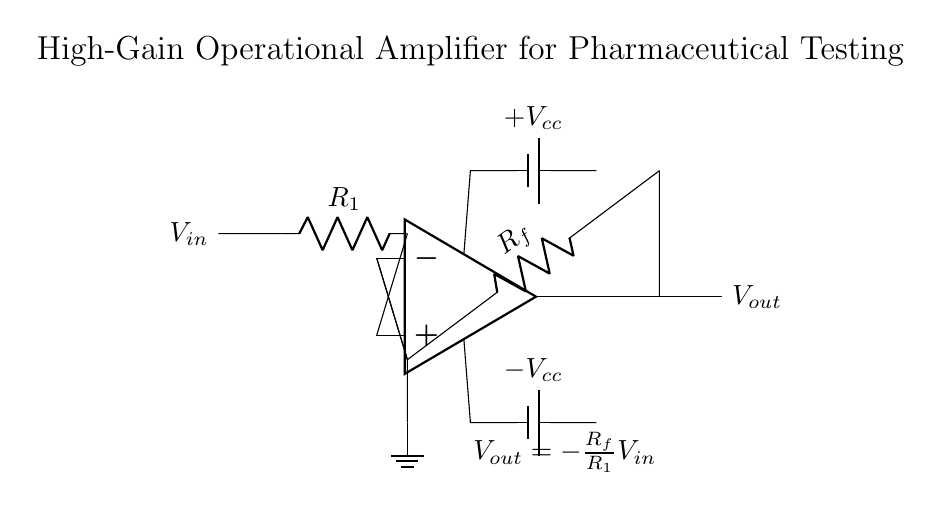What is the input voltage of this circuit? The input voltage is represented by the symbol V_in, which is shown entering the circuit from the left.
Answer: V_in What is the output voltage expression based on the circuit configuration? The output voltage expression is given by the label that shows V_out = -R_f/R_1 * V_in, which indicates how the output is calculated based on the input voltage and resistance values.
Answer: -R_f/R_1 * V_in What type of amplifier is utilized in this circuit? The circuit uses an operational amplifier (op-amp), indicated by the op-amp symbol in the diagram.
Answer: Operational amplifier What is the role of resistor R_f in this circuit? Resistor R_f is a feedback resistor, which is critical in determining the gain of the amplifier by creating a feedback loop from the output to the inverting input.
Answer: Feedback resistor Which components supply power to the op-amp? The op-amp is powered by two battery components labeled +V_cc and -V_cc, which provide the necessary positive and negative supply voltages.
Answer: +V_cc and -V_cc What is the gain of this amplifier circuit? The gain can be deduced from the relationship specified in the expression for V_out, which indicates that the gain is the negative ratio of R_f to R_1.
Answer: -R_f/R_1 What is indicated by the ground connection in this circuit? The ground connection signifies the reference point for the circuit, providing a common return path for the current and establishing a zero voltage level.
Answer: Reference point 